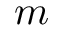Convert formula to latex. <formula><loc_0><loc_0><loc_500><loc_500>m</formula> 